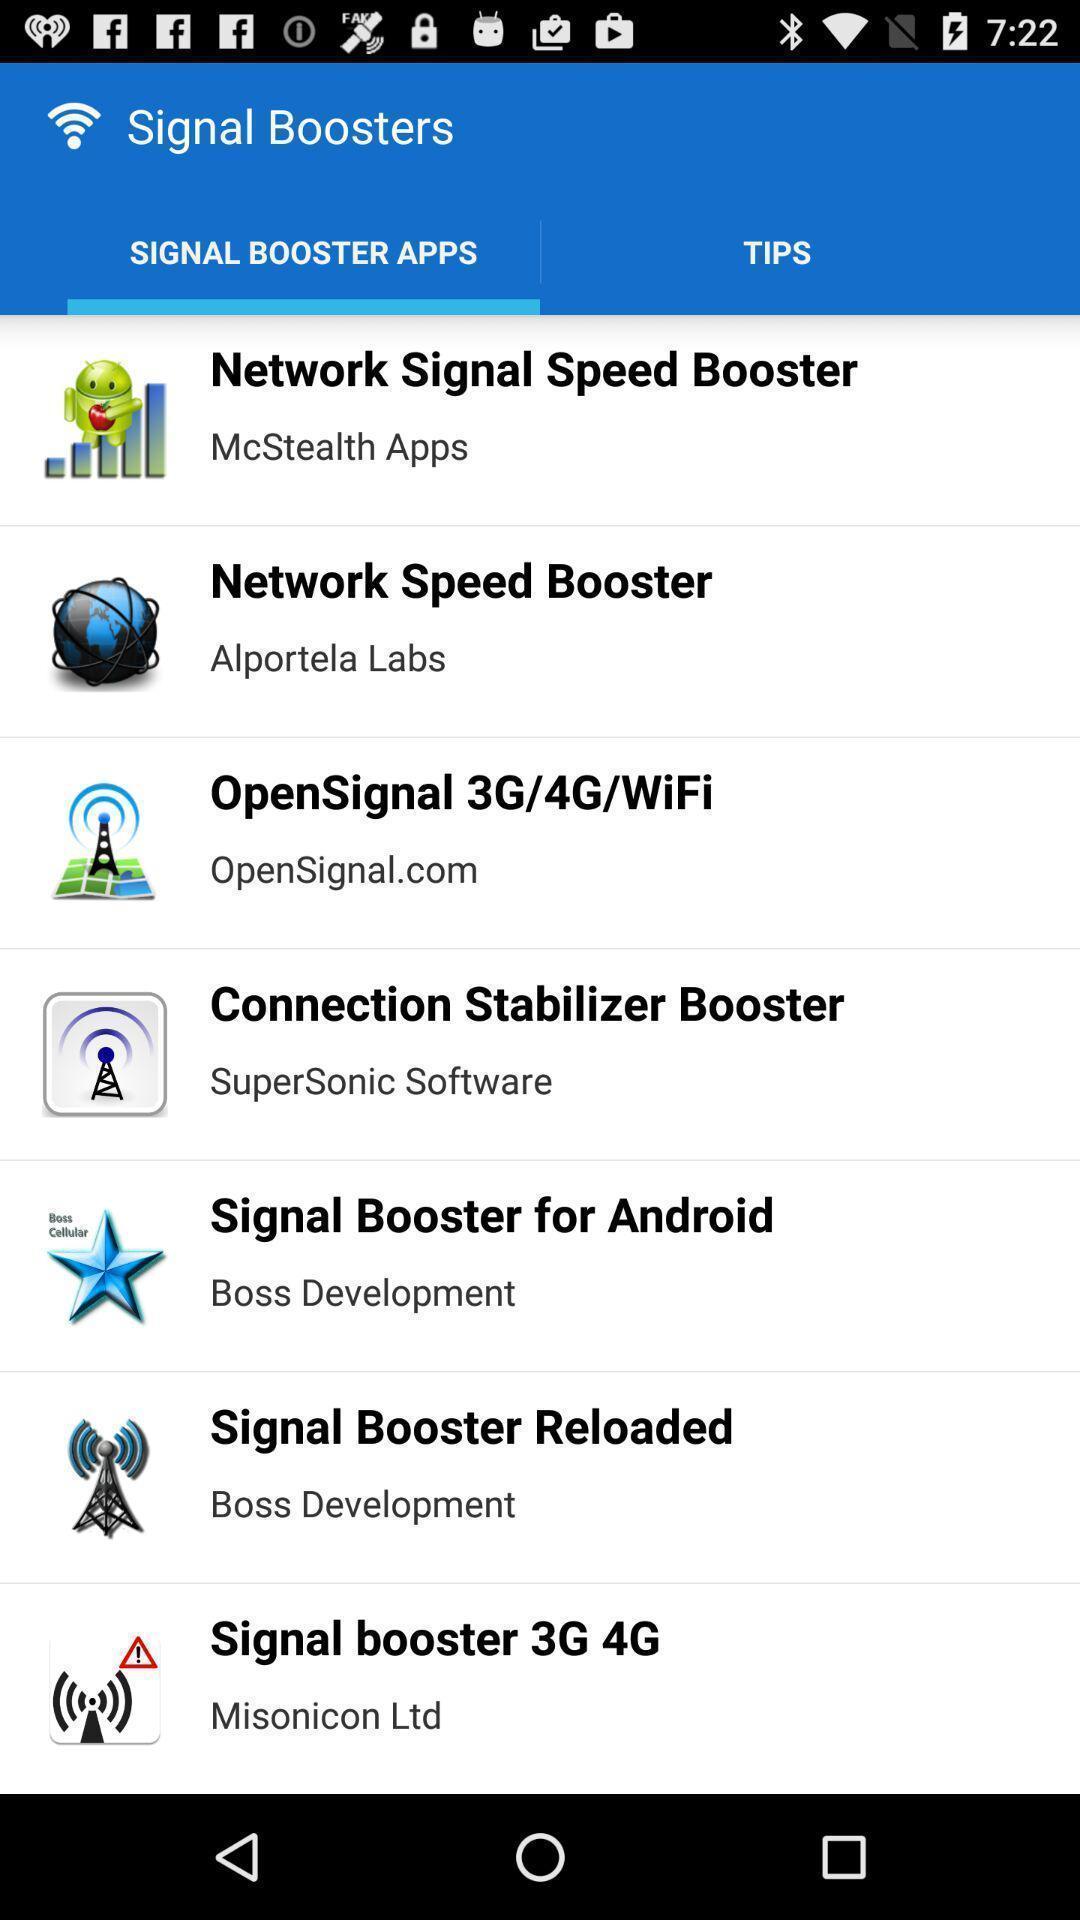Describe this image in words. Screen showing signal booster apps. 